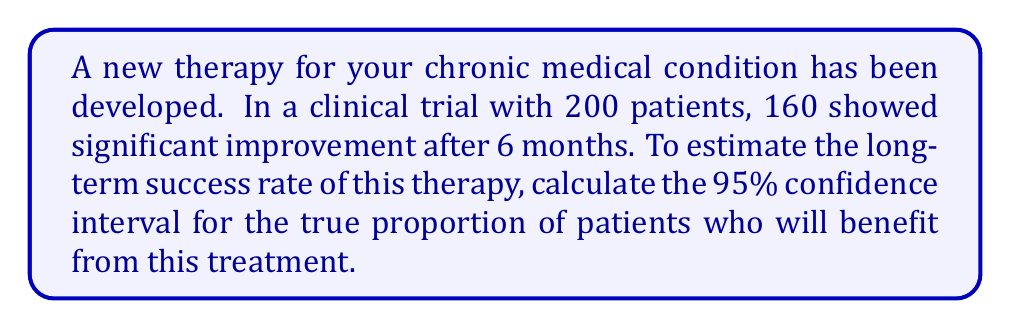Solve this math problem. To calculate the confidence interval for a proportion, we'll use the following steps:

1. Calculate the sample proportion:
   $\hat{p} = \frac{\text{number of successes}}{\text{total number of trials}} = \frac{160}{200} = 0.8$

2. Calculate the standard error of the proportion:
   $SE = \sqrt{\frac{\hat{p}(1-\hat{p})}{n}} = \sqrt{\frac{0.8(1-0.8)}{200}} = \sqrt{\frac{0.16}{200}} = 0.0283$

3. For a 95% confidence interval, we use a z-score of 1.96 (from the standard normal distribution).

4. Calculate the margin of error:
   $\text{Margin of Error} = z \cdot SE = 1.96 \cdot 0.0283 = 0.0555$

5. Calculate the confidence interval:
   $\text{CI} = \hat{p} \pm \text{Margin of Error}$
   $\text{CI} = 0.8 \pm 0.0555$
   $\text{Lower bound} = 0.8 - 0.0555 = 0.7445$
   $\text{Upper bound} = 0.8 + 0.0555 = 0.8555$

Therefore, we can be 95% confident that the true proportion of patients who will benefit from this treatment in the long term is between 0.7445 and 0.8555, or between 74.45% and 85.55%.
Answer: The 95% confidence interval for the long-term success rate of the new therapy is (0.7445, 0.8555) or (74.45%, 85.55%). 